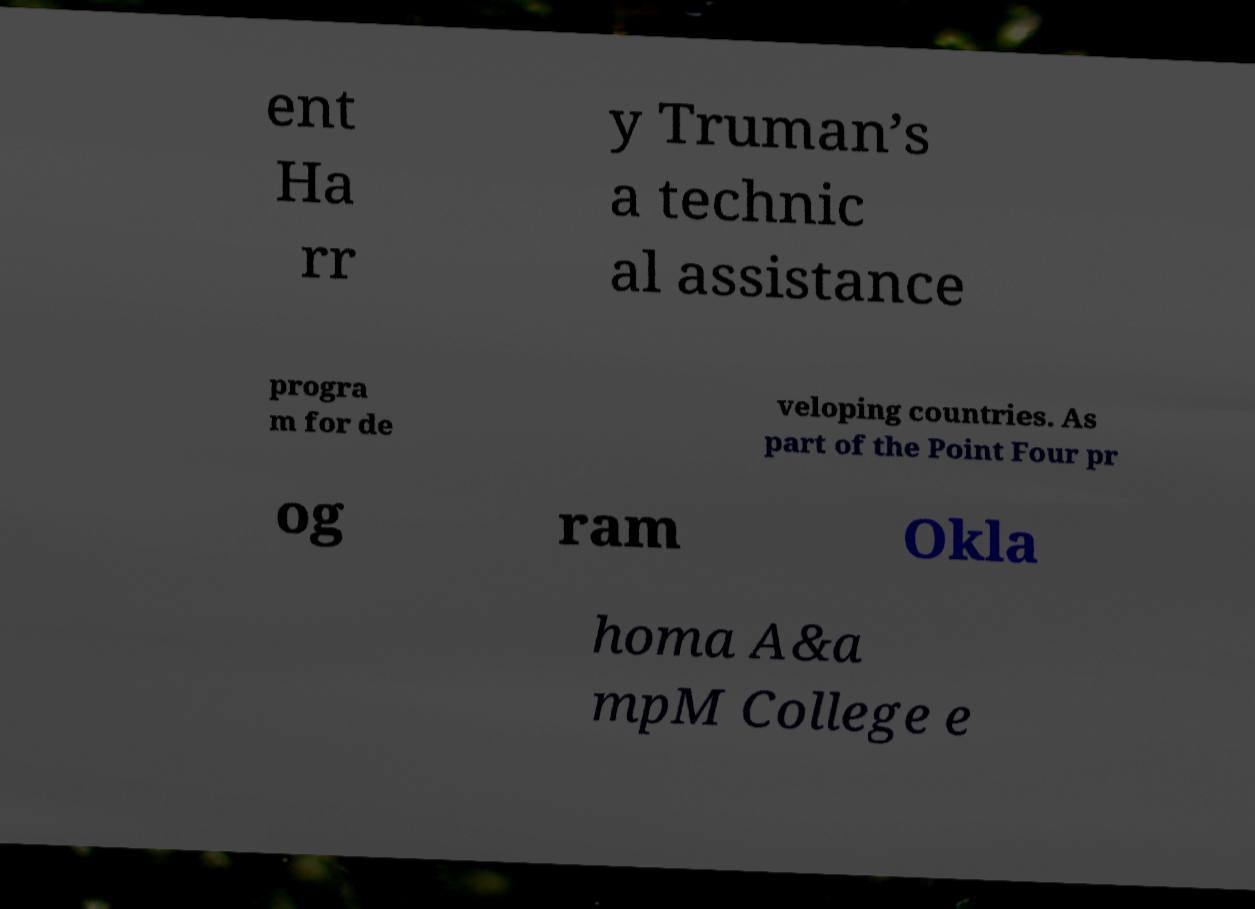I need the written content from this picture converted into text. Can you do that? ent Ha rr y Truman’s a technic al assistance progra m for de veloping countries. As part of the Point Four pr og ram Okla homa A&a mpM College e 